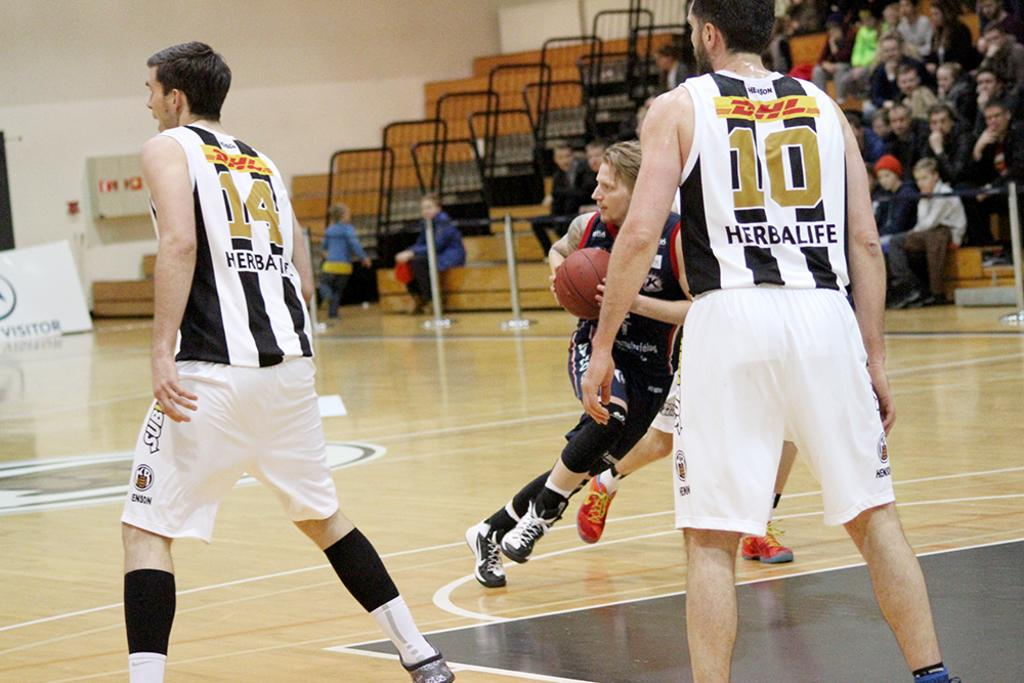What are the persons in the image doing? The persons in the image are playing. What object is being held by one of the persons? One person is holding a ball. Can you describe the people in the background? There is a group of people in the background. What additional element can be seen in the image? There is a banner in the image. What type of structure is present in the image? There is a wall in the image. What type of books can be seen on the wall in the image? There are no books visible on the wall in the image. Is there any printing visible on the banner in the image? The question does not specify any printing on the banner, so we cannot answer that question definitively. However, based on the facts provided, we can confirm that there is a banner present in the image. 